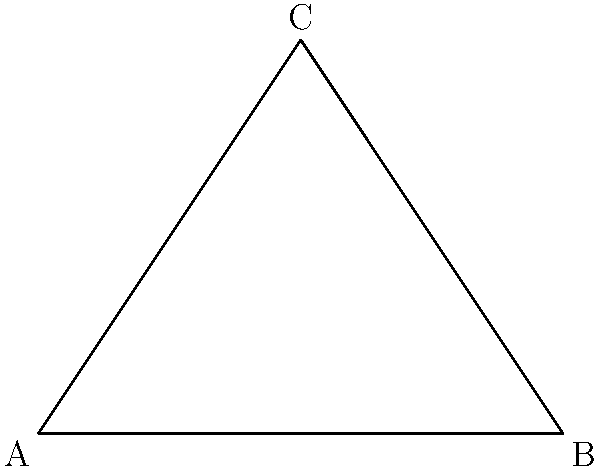In HVAC duct design, a hyperbolic triangle represents the cross-section of a non-standard duct junction. Given that the sum of the interior angles of this hyperbolic triangle is 150°, and two of the angles are 60° and 45° as shown in the diagram, what is the measure of the third angle? How does this relate to the defect of the hyperbolic triangle, and what implications does this have for airflow in HVAC systems? To solve this problem, we'll follow these steps:

1) In Euclidean geometry, the sum of angles in a triangle is always 180°. However, in hyperbolic geometry, this sum is always less than 180°.

2) The difference between 180° and the sum of angles in a hyperbolic triangle is called the defect. Let's call the defect $d$.

3) Given information:
   - Sum of angles = 150°
   - Two known angles: 60° and 45°

4) Calculate the defect:
   $d = 180° - 150° = 30°$

5) Let $x$ be the measure of the third angle. We can set up an equation:
   $60° + 45° + x = 150°$

6) Solve for $x$:
   $x = 150° - (60° + 45°) = 150° - 105° = 45°$

7) Verify: $60° + 45° + 45° = 150°$

8) The defect of 30° indicates that this is indeed a hyperbolic triangle, not a Euclidean one.

9) In HVAC systems, this non-Euclidean geometry implies that the duct junction doesn't conform to standard rectangular or circular shapes. The defect suggests a curvature in the space, which could affect airflow dynamics:
   - It may create areas of turbulence or dead zones where air doesn't flow smoothly.
   - It could lead to pressure drops that are different from what would be expected in Euclidean geometry.
   - The unusual angles might require special manufacturing techniques to ensure proper fit and seal.

10) Understanding these geometrical properties is crucial for HVAC manufacturers to design efficient systems that comply with industry regulations on airflow, energy efficiency, and noise reduction.
Answer: 45°; The 30° defect indicates hyperbolic geometry, potentially causing non-standard airflow patterns in HVAC ducts. 